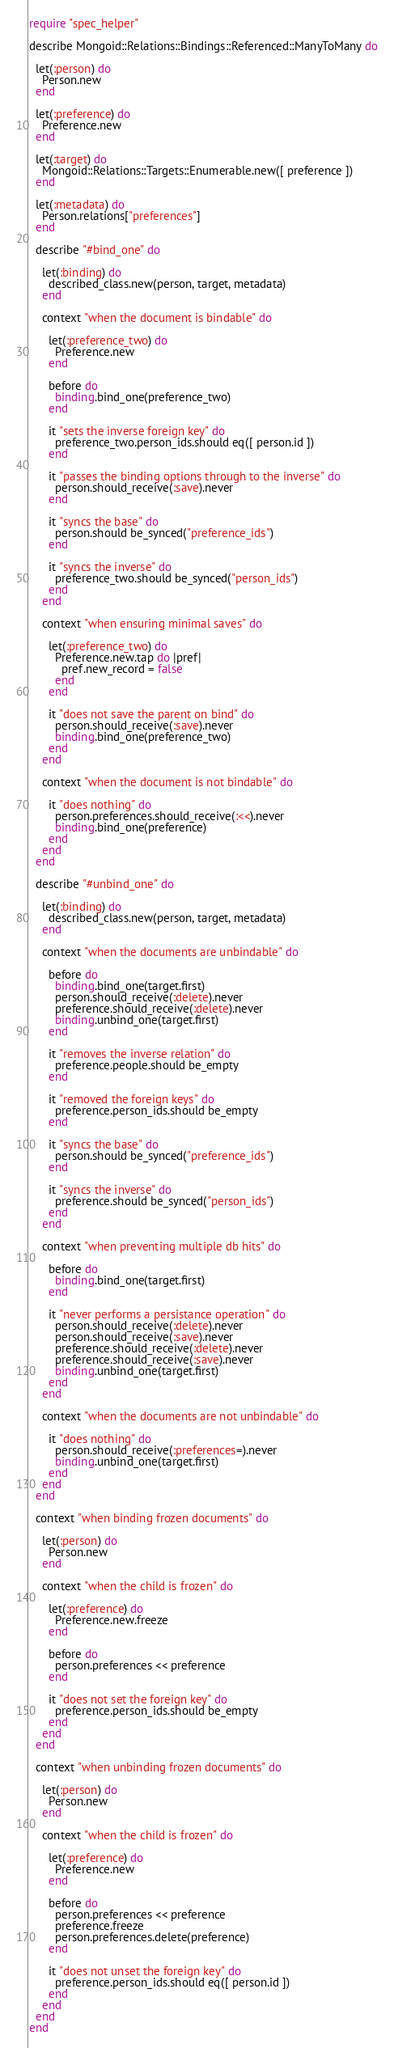<code> <loc_0><loc_0><loc_500><loc_500><_Ruby_>require "spec_helper"

describe Mongoid::Relations::Bindings::Referenced::ManyToMany do

  let(:person) do
    Person.new
  end

  let(:preference) do
    Preference.new
  end

  let(:target) do
    Mongoid::Relations::Targets::Enumerable.new([ preference ])
  end

  let(:metadata) do
    Person.relations["preferences"]
  end

  describe "#bind_one" do

    let(:binding) do
      described_class.new(person, target, metadata)
    end

    context "when the document is bindable" do

      let(:preference_two) do
        Preference.new
      end

      before do
        binding.bind_one(preference_two)
      end

      it "sets the inverse foreign key" do
        preference_two.person_ids.should eq([ person.id ])
      end

      it "passes the binding options through to the inverse" do
        person.should_receive(:save).never
      end

      it "syncs the base" do
        person.should be_synced("preference_ids")
      end

      it "syncs the inverse" do
        preference_two.should be_synced("person_ids")
      end
    end

    context "when ensuring minimal saves" do

      let(:preference_two) do
        Preference.new.tap do |pref|
          pref.new_record = false
        end
      end

      it "does not save the parent on bind" do
        person.should_receive(:save).never
        binding.bind_one(preference_two)
      end
    end

    context "when the document is not bindable" do

      it "does nothing" do
        person.preferences.should_receive(:<<).never
        binding.bind_one(preference)
      end
    end
  end

  describe "#unbind_one" do

    let(:binding) do
      described_class.new(person, target, metadata)
    end

    context "when the documents are unbindable" do

      before do
        binding.bind_one(target.first)
        person.should_receive(:delete).never
        preference.should_receive(:delete).never
        binding.unbind_one(target.first)
      end

      it "removes the inverse relation" do
        preference.people.should be_empty
      end

      it "removed the foreign keys" do
        preference.person_ids.should be_empty
      end

      it "syncs the base" do
        person.should be_synced("preference_ids")
      end

      it "syncs the inverse" do
        preference.should be_synced("person_ids")
      end
    end

    context "when preventing multiple db hits" do

      before do
        binding.bind_one(target.first)
      end

      it "never performs a persistance operation" do
        person.should_receive(:delete).never
        person.should_receive(:save).never
        preference.should_receive(:delete).never
        preference.should_receive(:save).never
        binding.unbind_one(target.first)
      end
    end

    context "when the documents are not unbindable" do

      it "does nothing" do
        person.should_receive(:preferences=).never
        binding.unbind_one(target.first)
      end
    end
  end

  context "when binding frozen documents" do

    let(:person) do
      Person.new
    end

    context "when the child is frozen" do

      let(:preference) do
        Preference.new.freeze
      end

      before do
        person.preferences << preference
      end

      it "does not set the foreign key" do
        preference.person_ids.should be_empty
      end
    end
  end

  context "when unbinding frozen documents" do

    let(:person) do
      Person.new
    end

    context "when the child is frozen" do

      let(:preference) do
        Preference.new
      end

      before do
        person.preferences << preference
        preference.freeze
        person.preferences.delete(preference)
      end

      it "does not unset the foreign key" do
        preference.person_ids.should eq([ person.id ])
      end
    end
  end
end
</code> 